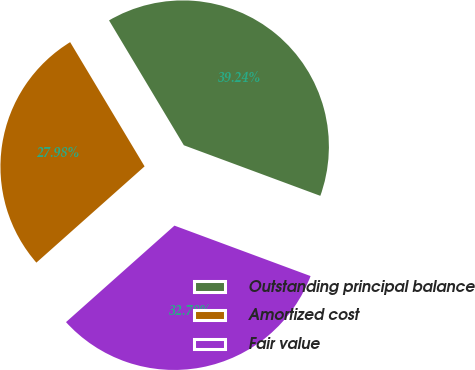<chart> <loc_0><loc_0><loc_500><loc_500><pie_chart><fcel>Outstanding principal balance<fcel>Amortized cost<fcel>Fair value<nl><fcel>39.24%<fcel>27.98%<fcel>32.78%<nl></chart> 